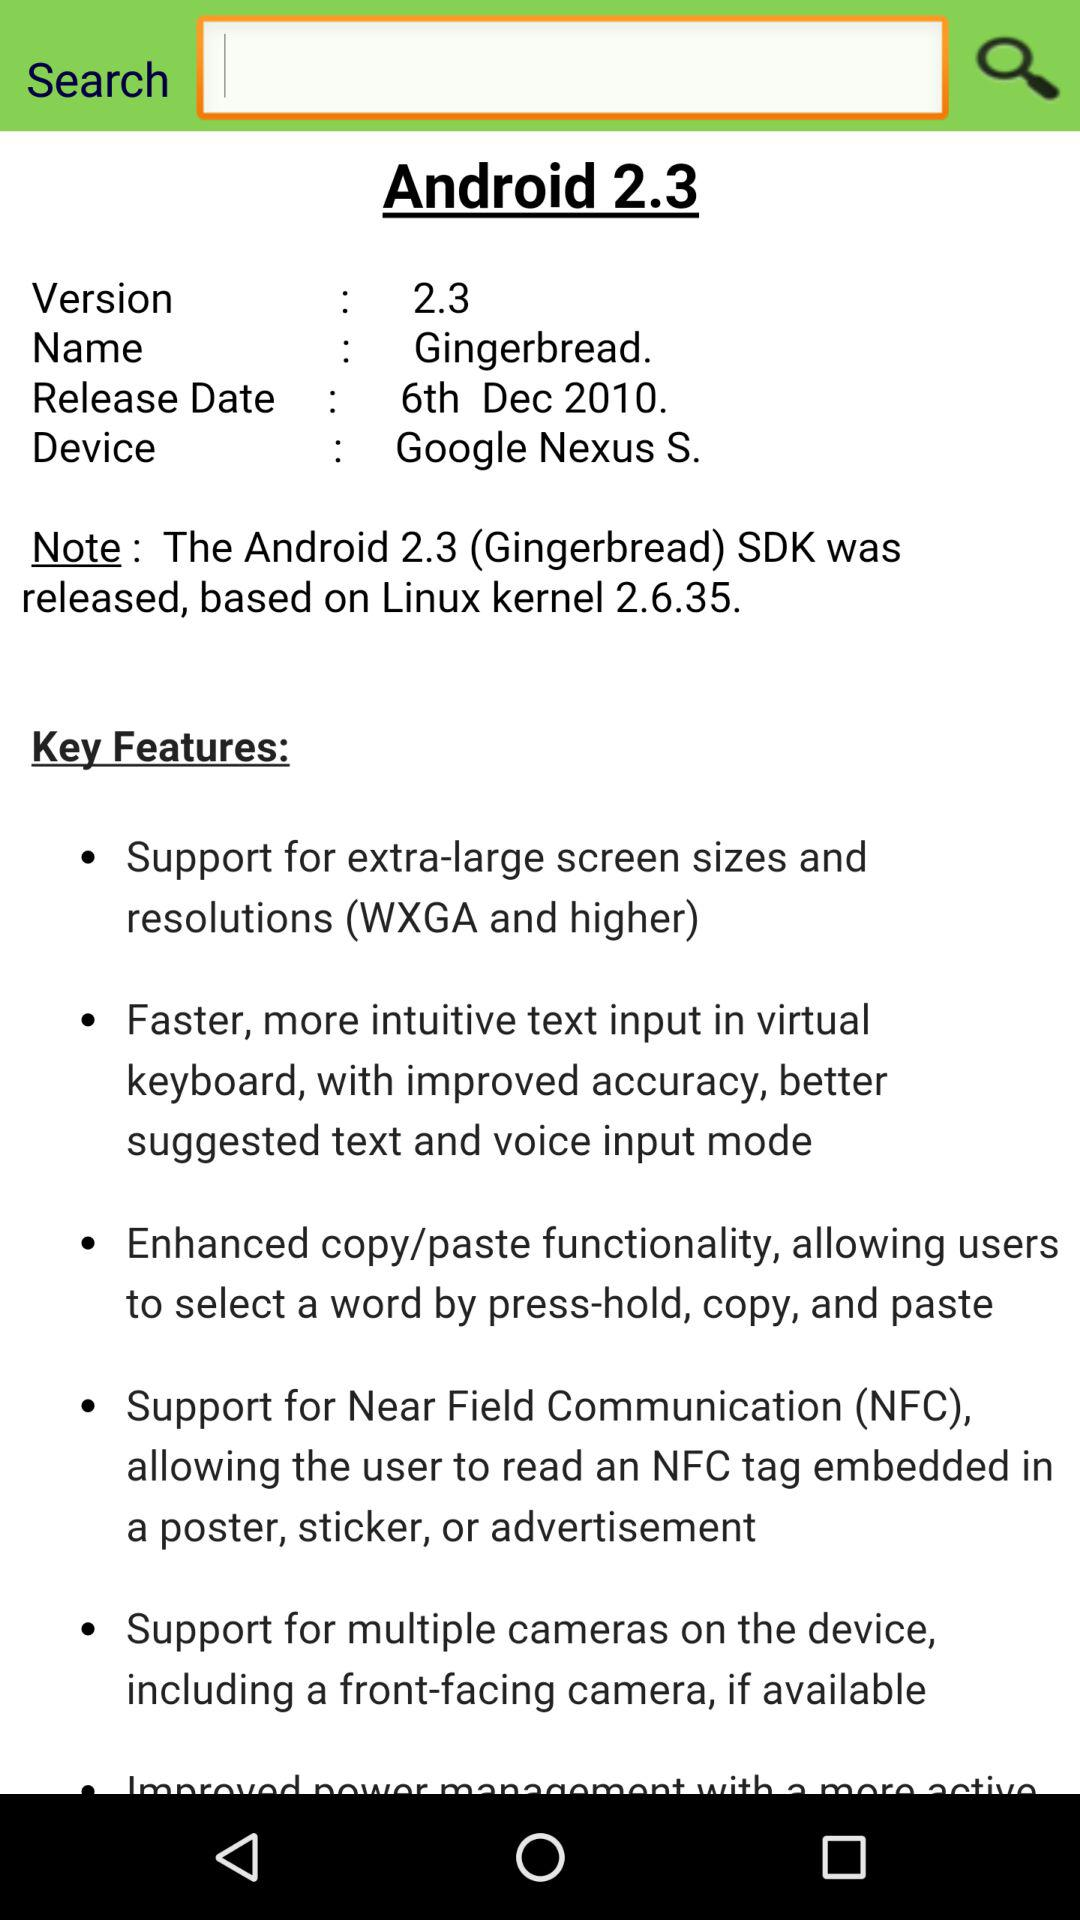On which Linux kernel version was the Android 2.3 SDK released? The Android 2.3 SDK was released based on the Linux kernel version 2.6.35. 